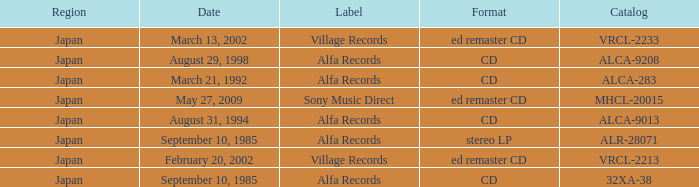Parse the full table. {'header': ['Region', 'Date', 'Label', 'Format', 'Catalog'], 'rows': [['Japan', 'March 13, 2002', 'Village Records', 'ed remaster CD', 'VRCL-2233'], ['Japan', 'August 29, 1998', 'Alfa Records', 'CD', 'ALCA-9208'], ['Japan', 'March 21, 1992', 'Alfa Records', 'CD', 'ALCA-283'], ['Japan', 'May 27, 2009', 'Sony Music Direct', 'ed remaster CD', 'MHCL-20015'], ['Japan', 'August 31, 1994', 'Alfa Records', 'CD', 'ALCA-9013'], ['Japan', 'September 10, 1985', 'Alfa Records', 'stereo LP', 'ALR-28071'], ['Japan', 'February 20, 2002', 'Village Records', 'ed remaster CD', 'VRCL-2213'], ['Japan', 'September 10, 1985', 'Alfa Records', 'CD', '32XA-38']]} Which Catalog was formated as a CD under the label Alfa Records? 32XA-38, ALCA-283, ALCA-9013, ALCA-9208. 